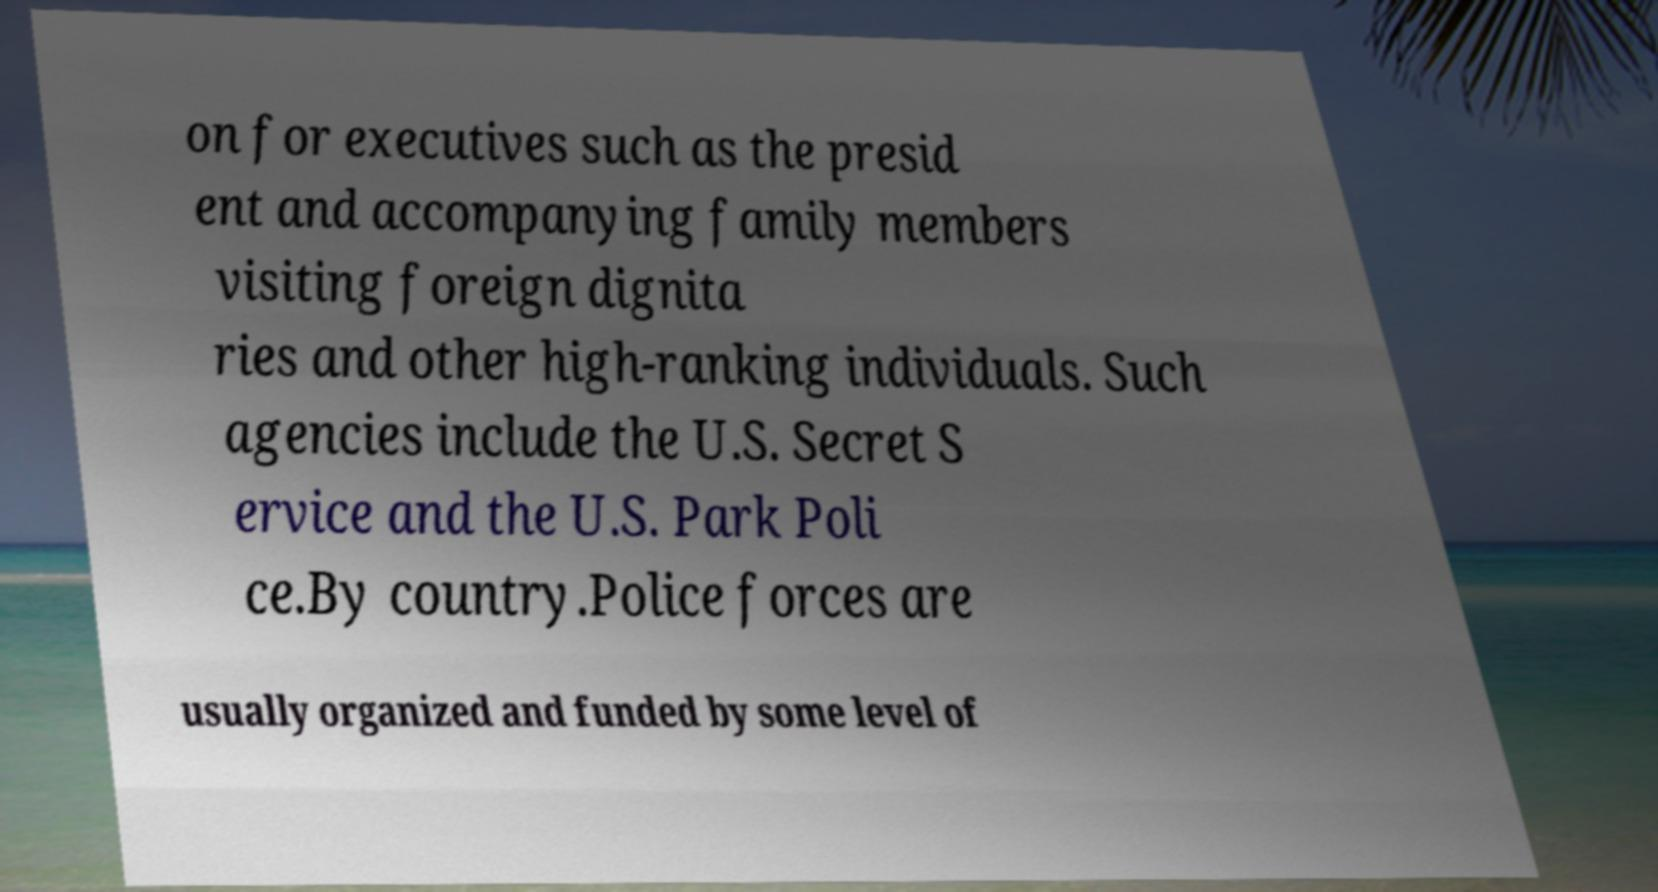I need the written content from this picture converted into text. Can you do that? on for executives such as the presid ent and accompanying family members visiting foreign dignita ries and other high-ranking individuals. Such agencies include the U.S. Secret S ervice and the U.S. Park Poli ce.By country.Police forces are usually organized and funded by some level of 